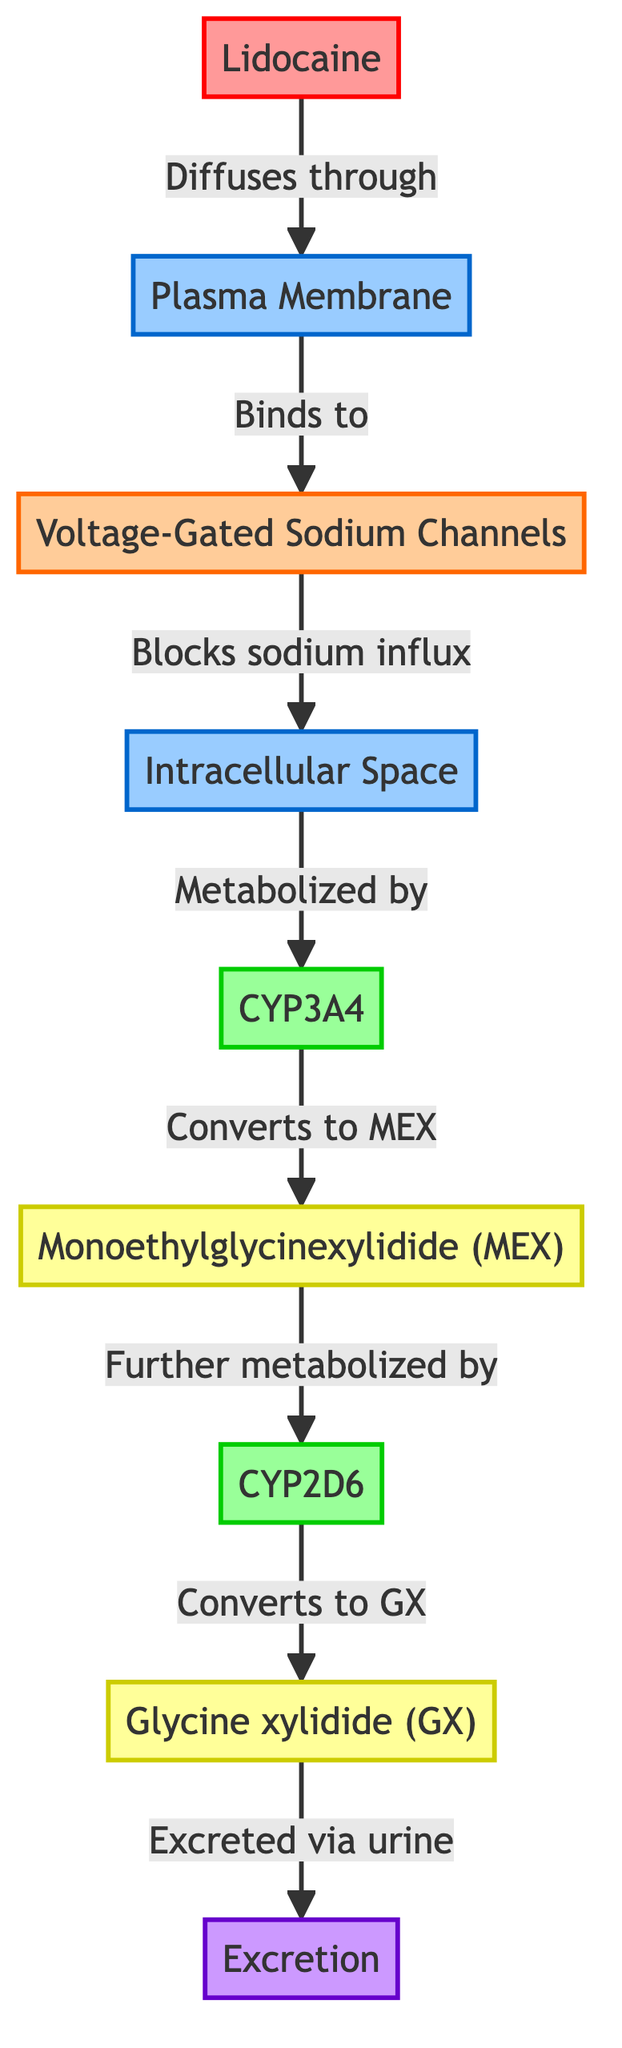What's the first molecule that enters the pathway? The pathway begins with Lidocaine, which diffuses through the plasma membrane.
Answer: Lidocaine How many enzymes are involved in the pathway? There are two enzymes present in the pathway, CYP3A4 and CYP2D6.
Answer: 2 What does Lidocaine bind to after diffusing through the plasma membrane? After diffusing, Lidocaine binds to Voltage-Gated Sodium Channels.
Answer: Voltage-Gated Sodium Channels What is the first metabolite produced from Lidocaine? The first metabolite generated from the metabolism of Lidocaine is Monoethylglycinexylidide (MEX) after it is processed by the enzyme CYP3A4.
Answer: Monoethylglycinexylidide (MEX) Which two metabolites are formed as a result of the enzymatic reactions? The two metabolites produced are Monoethylglycinexylidide (MEX) and Glycine xylidide (GX).
Answer: Monoethylglycinexylidide (MEX), Glycine xylidide (GX) What is the final process described in the diagram? The diagram indicates that Glycine xylidide (GX) is excreted via urine, which is the final process.
Answer: Excretion What role does CYP2D6 play in the pathway? CYP2D6 further metabolizes the first metabolite, MEX, converting it into the second metabolite, GX.
Answer: Converts to GX What happens to the sodium influx when Lidocaine binds to the sodium channels? When Lidocaine binds, it blocks the sodium influx into the intracellular space, inhibiting nerve signal transmission.
Answer: Blocks sodium influx How does Lidocaine enter the animal cell? Lidocaine enters the cell by diffusing through the plasma membrane.
Answer: Diffuses through 